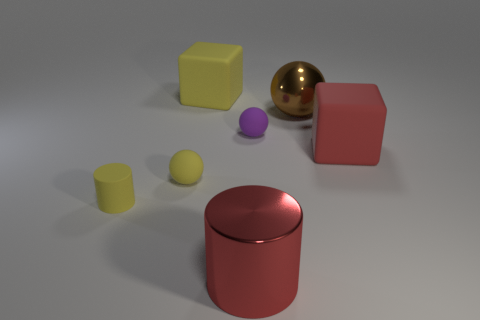Add 1 large red blocks. How many objects exist? 8 Subtract all gray balls. Subtract all green cylinders. How many balls are left? 3 Subtract all blocks. How many objects are left? 5 Subtract 0 purple blocks. How many objects are left? 7 Subtract all rubber cubes. Subtract all yellow objects. How many objects are left? 2 Add 3 brown metallic things. How many brown metallic things are left? 4 Add 2 big shiny things. How many big shiny things exist? 4 